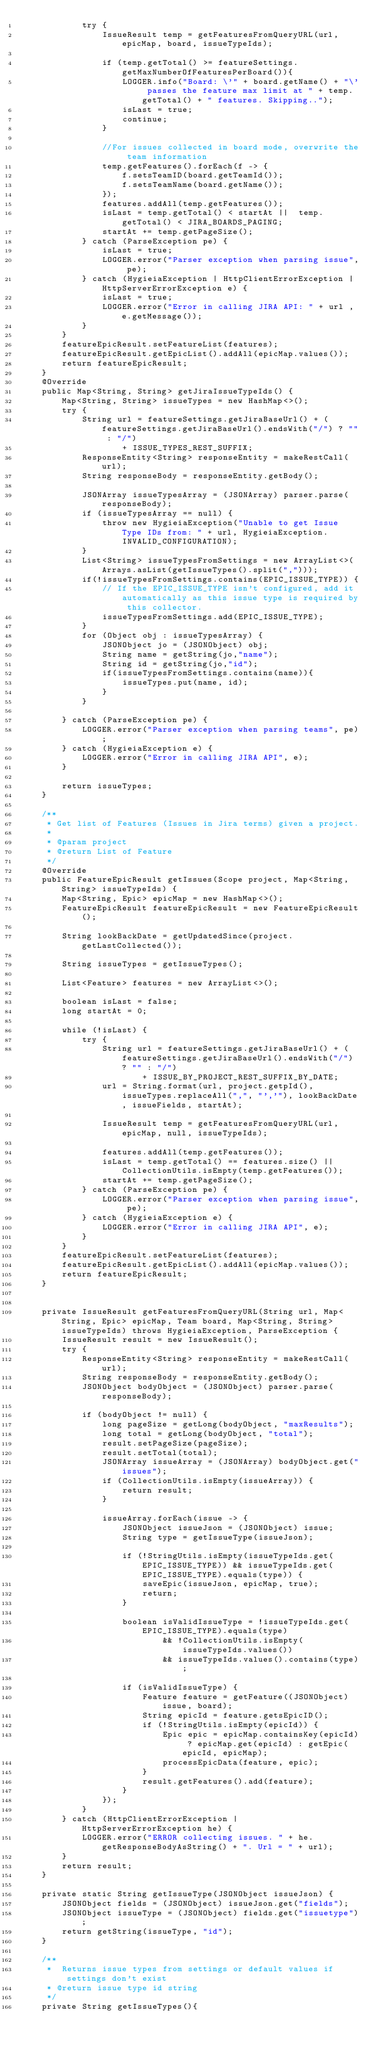<code> <loc_0><loc_0><loc_500><loc_500><_Java_>            try {
                IssueResult temp = getFeaturesFromQueryURL(url, epicMap, board, issueTypeIds);

                if (temp.getTotal() >= featureSettings.getMaxNumberOfFeaturesPerBoard()){
                    LOGGER.info("Board: \'" + board.getName() + "\' passes the feature max limit at " + temp.getTotal() + " features. Skipping..");
                    isLast = true;
                    continue;
                }

                //For issues collected in board mode, overwrite the team information
                temp.getFeatures().forEach(f -> {
                    f.setsTeamID(board.getTeamId());
                    f.setsTeamName(board.getName());
                });
                features.addAll(temp.getFeatures());
                isLast = temp.getTotal() < startAt ||  temp.getTotal() < JIRA_BOARDS_PAGING;
                startAt += temp.getPageSize();
            } catch (ParseException pe) {
                isLast = true;
                LOGGER.error("Parser exception when parsing issue", pe);
            } catch (HygieiaException | HttpClientErrorException | HttpServerErrorException e) {
                isLast = true;
                LOGGER.error("Error in calling JIRA API: " + url , e.getMessage());
            }
        }
        featureEpicResult.setFeatureList(features);
        featureEpicResult.getEpicList().addAll(epicMap.values());
        return featureEpicResult;
    }
    @Override
    public Map<String, String> getJiraIssueTypeIds() {
        Map<String, String> issueTypes = new HashMap<>();
        try {
            String url = featureSettings.getJiraBaseUrl() + (featureSettings.getJiraBaseUrl().endsWith("/") ? "" : "/")
                    + ISSUE_TYPES_REST_SUFFIX;
            ResponseEntity<String> responseEntity = makeRestCall(url);
            String responseBody = responseEntity.getBody();

            JSONArray issueTypesArray = (JSONArray) parser.parse(responseBody);
            if (issueTypesArray == null) {
                throw new HygieiaException("Unable to get Issue Type IDs from: " + url, HygieiaException.INVALID_CONFIGURATION);
            }
            List<String> issueTypesFromSettings = new ArrayList<>(Arrays.asList(getIssueTypes().split(",")));
            if(!issueTypesFromSettings.contains(EPIC_ISSUE_TYPE)) {
                // If the EPIC_ISSUE_TYPE isn't configured, add it automatically as this issue type is required by this collector.
                issueTypesFromSettings.add(EPIC_ISSUE_TYPE);
            }
            for (Object obj : issueTypesArray) {
                JSONObject jo = (JSONObject) obj;
                String name = getString(jo,"name");
                String id = getString(jo,"id");
                if(issueTypesFromSettings.contains(name)){
                    issueTypes.put(name, id);
                }
            }

        } catch (ParseException pe) {
            LOGGER.error("Parser exception when parsing teams", pe);
        } catch (HygieiaException e) {
            LOGGER.error("Error in calling JIRA API", e);
        }

        return issueTypes;
    }

    /**
     * Get list of Features (Issues in Jira terms) given a project.
     *
     * @param project
     * @return List of Feature
     */
    @Override
    public FeatureEpicResult getIssues(Scope project, Map<String, String> issueTypeIds) {
        Map<String, Epic> epicMap = new HashMap<>();
        FeatureEpicResult featureEpicResult = new FeatureEpicResult();

        String lookBackDate = getUpdatedSince(project.getLastCollected());

        String issueTypes = getIssueTypes();

        List<Feature> features = new ArrayList<>();

        boolean isLast = false;
        long startAt = 0;

        while (!isLast) {
            try {
                String url = featureSettings.getJiraBaseUrl() + (featureSettings.getJiraBaseUrl().endsWith("/") ? "" : "/")
                        + ISSUE_BY_PROJECT_REST_SUFFIX_BY_DATE;
                url = String.format(url, project.getpId(), issueTypes.replaceAll(",", "','"), lookBackDate, issueFields, startAt);

                IssueResult temp = getFeaturesFromQueryURL(url, epicMap, null, issueTypeIds);

                features.addAll(temp.getFeatures());
                isLast = temp.getTotal() == features.size() || CollectionUtils.isEmpty(temp.getFeatures());
                startAt += temp.getPageSize();
            } catch (ParseException pe) {
                LOGGER.error("Parser exception when parsing issue", pe);
            } catch (HygieiaException e) {
                LOGGER.error("Error in calling JIRA API", e);
            }
        }
        featureEpicResult.setFeatureList(features);
        featureEpicResult.getEpicList().addAll(epicMap.values());
        return featureEpicResult;
    }


    private IssueResult getFeaturesFromQueryURL(String url, Map<String, Epic> epicMap, Team board, Map<String, String> issueTypeIds) throws HygieiaException, ParseException {
        IssueResult result = new IssueResult();
        try {
            ResponseEntity<String> responseEntity = makeRestCall(url);
            String responseBody = responseEntity.getBody();
            JSONObject bodyObject = (JSONObject) parser.parse(responseBody);

            if (bodyObject != null) {
                long pageSize = getLong(bodyObject, "maxResults");
                long total = getLong(bodyObject, "total");
                result.setPageSize(pageSize);
                result.setTotal(total);
                JSONArray issueArray = (JSONArray) bodyObject.get("issues");
                if (CollectionUtils.isEmpty(issueArray)) {
                    return result;
                }

                issueArray.forEach(issue -> {
                    JSONObject issueJson = (JSONObject) issue;
                    String type = getIssueType(issueJson);

                    if (!StringUtils.isEmpty(issueTypeIds.get(EPIC_ISSUE_TYPE)) && issueTypeIds.get(EPIC_ISSUE_TYPE).equals(type)) {
                        saveEpic(issueJson, epicMap, true);
                        return;
                    }

                    boolean isValidIssueType = !issueTypeIds.get(EPIC_ISSUE_TYPE).equals(type)
                            && !CollectionUtils.isEmpty(issueTypeIds.values())
                            && issueTypeIds.values().contains(type);

                    if (isValidIssueType) {
                        Feature feature = getFeature((JSONObject) issue, board);
                        String epicId = feature.getsEpicID();
                        if (!StringUtils.isEmpty(epicId)) {
                            Epic epic = epicMap.containsKey(epicId) ? epicMap.get(epicId) : getEpic(epicId, epicMap);
                            processEpicData(feature, epic);
                        }
                        result.getFeatures().add(feature);
                    }
                });
            }
        } catch (HttpClientErrorException | HttpServerErrorException he) {
            LOGGER.error("ERROR collecting issues. " + he.getResponseBodyAsString() + ". Url = " + url);
        }
        return result;
    }

    private static String getIssueType(JSONObject issueJson) {
        JSONObject fields = (JSONObject) issueJson.get("fields");
        JSONObject issueType = (JSONObject) fields.get("issuetype");
        return getString(issueType, "id");
    }

    /**
     *  Returns issue types from settings or default values if settings don't exist
     * @return issue type id string
     */
    private String getIssueTypes(){</code> 